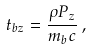Convert formula to latex. <formula><loc_0><loc_0><loc_500><loc_500>t _ { b z } = \frac { \rho P _ { z } } { m _ { b } c } \, ,</formula> 